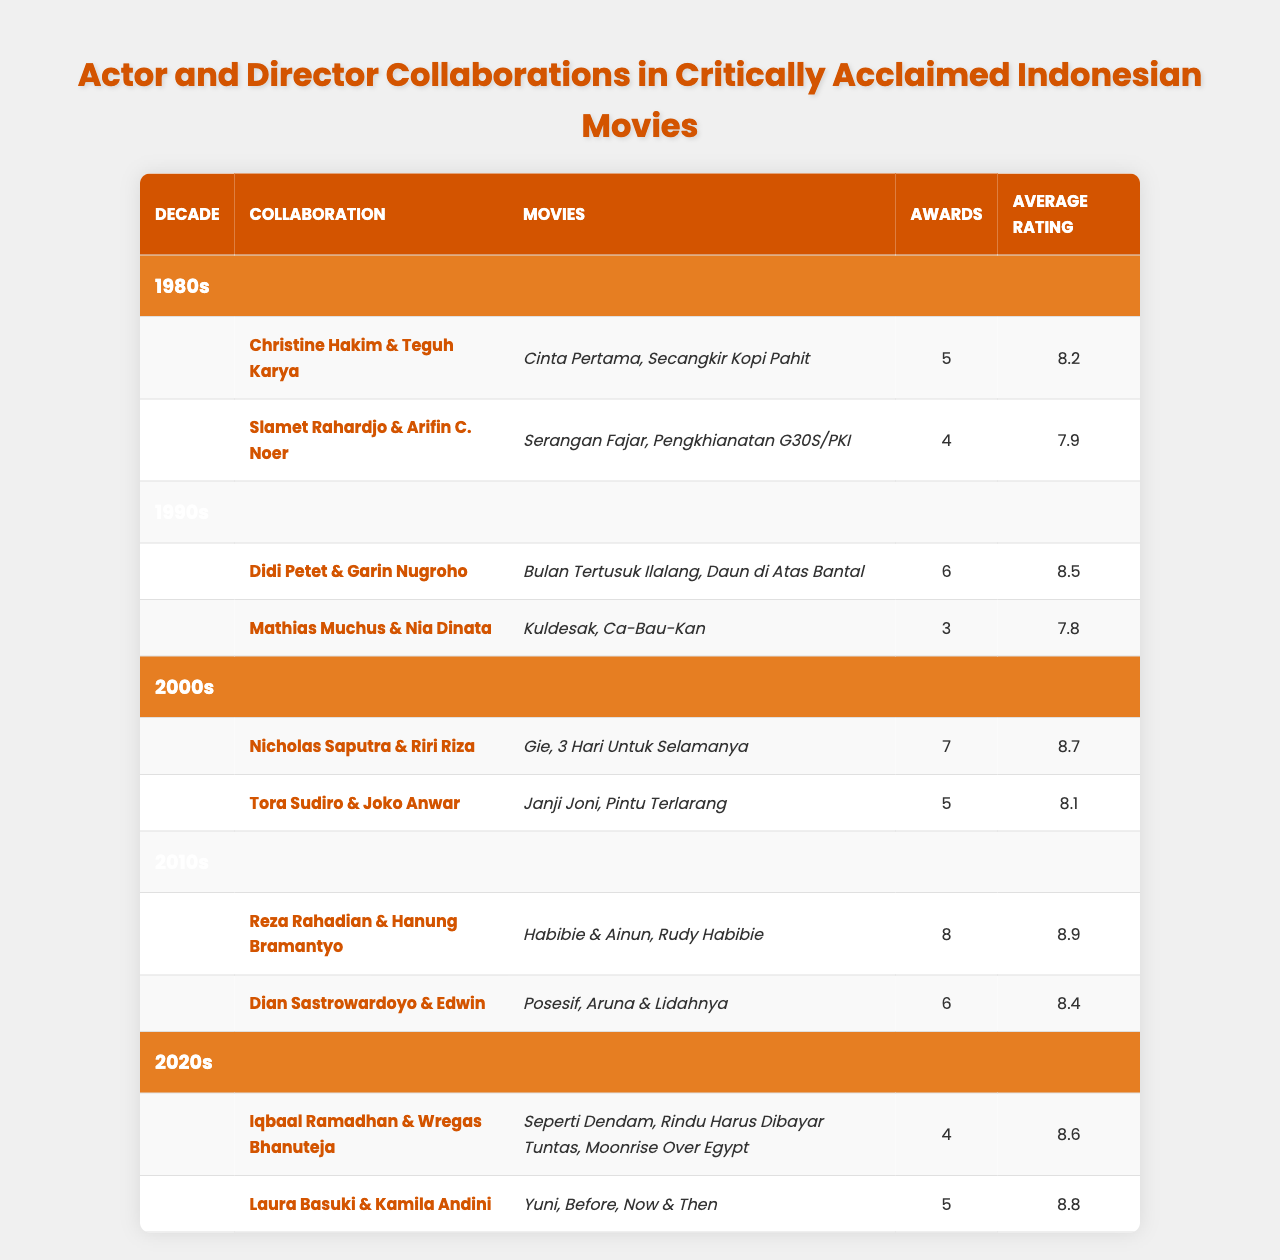What decade had the highest average rating for actor and director collaborations? Looking at the average ratings, the 2010s has the highest average rating of 8.9, provided by the collaboration of Reza Rahadian & Hanung Bramantyo.
Answer: 2010s How many awards did Nicholas Saputra & Riri Riza win? According to the table, Nicholas Saputra & Riri Riza won a total of 7 awards for their collaborations.
Answer: 7 Which collaboration received the most awards in the 1990s? In the 1990s, the collaboration between Didi Petet & Garin Nugroho received 6 awards, which is more than the 3 awards won by Mathias Muchus & Nia Dinata.
Answer: Didi Petet & Garin Nugroho Is the average rating for Laura Basuki & Kamila Andini higher than 8.5? The average rating for Laura Basuki & Kamila Andini is 8.8, which is higher than 8.5.
Answer: Yes What is the total number of awards won by collaborations in the 2000s? Nicholas Saputra & Riri Riza won 7 awards and Tora Sudiro & Joko Anwar won 5 awards in the 2000s, so the total is 7 + 5 = 12 awards.
Answer: 12 Which actor-director collaboration had the lowest average rating in the 1980s? In the 1980s, the collaboration between Slamet Rahardjo & Arifin C. Noer had the lowest average rating of 7.9 compared to Christine Hakim & Teguh Karya's 8.2.
Answer: Slamet Rahardjo & Arifin C. Noer How does the average rating of collaborations in the 2020s compare to that in the 1990s? In the 2020s, the average rating is 8.7 (average of Iqbaal Ramadhan & Wregas Bhanuteja and Laura Basuki & Kamila Andini), while in the 1990s, it is 8.15. Therefore, the 2020s has a higher average rating.
Answer: Higher Which era had the greatest number of films associated with its highest award-winning collaboration? Reza Rahadian & Hanung Bramantyo's collaboration in the 2010s had the highest number of awards (8) and it is associated with 2 films.
Answer: 2 films in the 2010s If we were to rank the decades based on the total awards won, which decade comes first? The total awards by decade are: 1980s (9), 1990s (9), 2000s (12), 2010s (14), 2020s (9). The 2010s had the most awards, hence it comes first.
Answer: 2010s How many total movies are listed for the decades of 1980s and 1990s? In the 1980s, there are 2 movies and in the 1990s, there are also 2 movies, totaling 2 + 2 = 4 movies.
Answer: 4 movies 